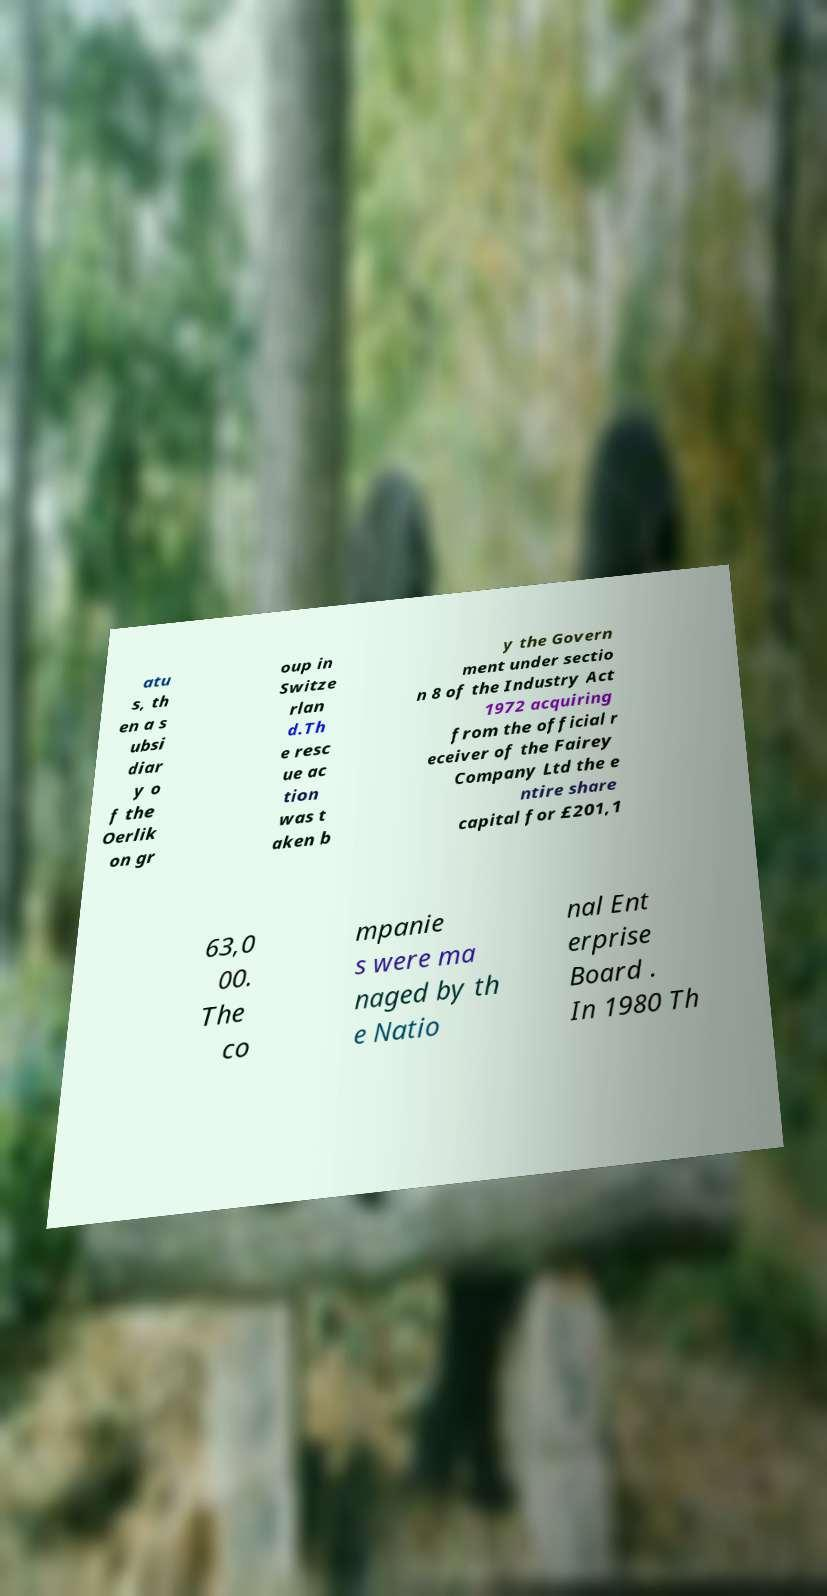Could you assist in decoding the text presented in this image and type it out clearly? atu s, th en a s ubsi diar y o f the Oerlik on gr oup in Switze rlan d.Th e resc ue ac tion was t aken b y the Govern ment under sectio n 8 of the Industry Act 1972 acquiring from the official r eceiver of the Fairey Company Ltd the e ntire share capital for £201,1 63,0 00. The co mpanie s were ma naged by th e Natio nal Ent erprise Board . In 1980 Th 